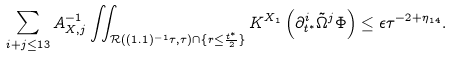<formula> <loc_0><loc_0><loc_500><loc_500>\sum _ { i + j \leq 1 3 } A _ { X , j } ^ { - 1 } \iint _ { \mathcal { R } ( ( 1 . 1 ) ^ { - 1 } \tau , \tau ) \cap \{ r \leq \frac { t ^ { * } } { 2 } \} } K ^ { X _ { 1 } } \left ( \partial _ { t ^ { * } } ^ { i } \tilde { \Omega } ^ { j } \Phi \right ) \leq \epsilon \tau ^ { - 2 + \eta _ { 1 4 } } .</formula> 